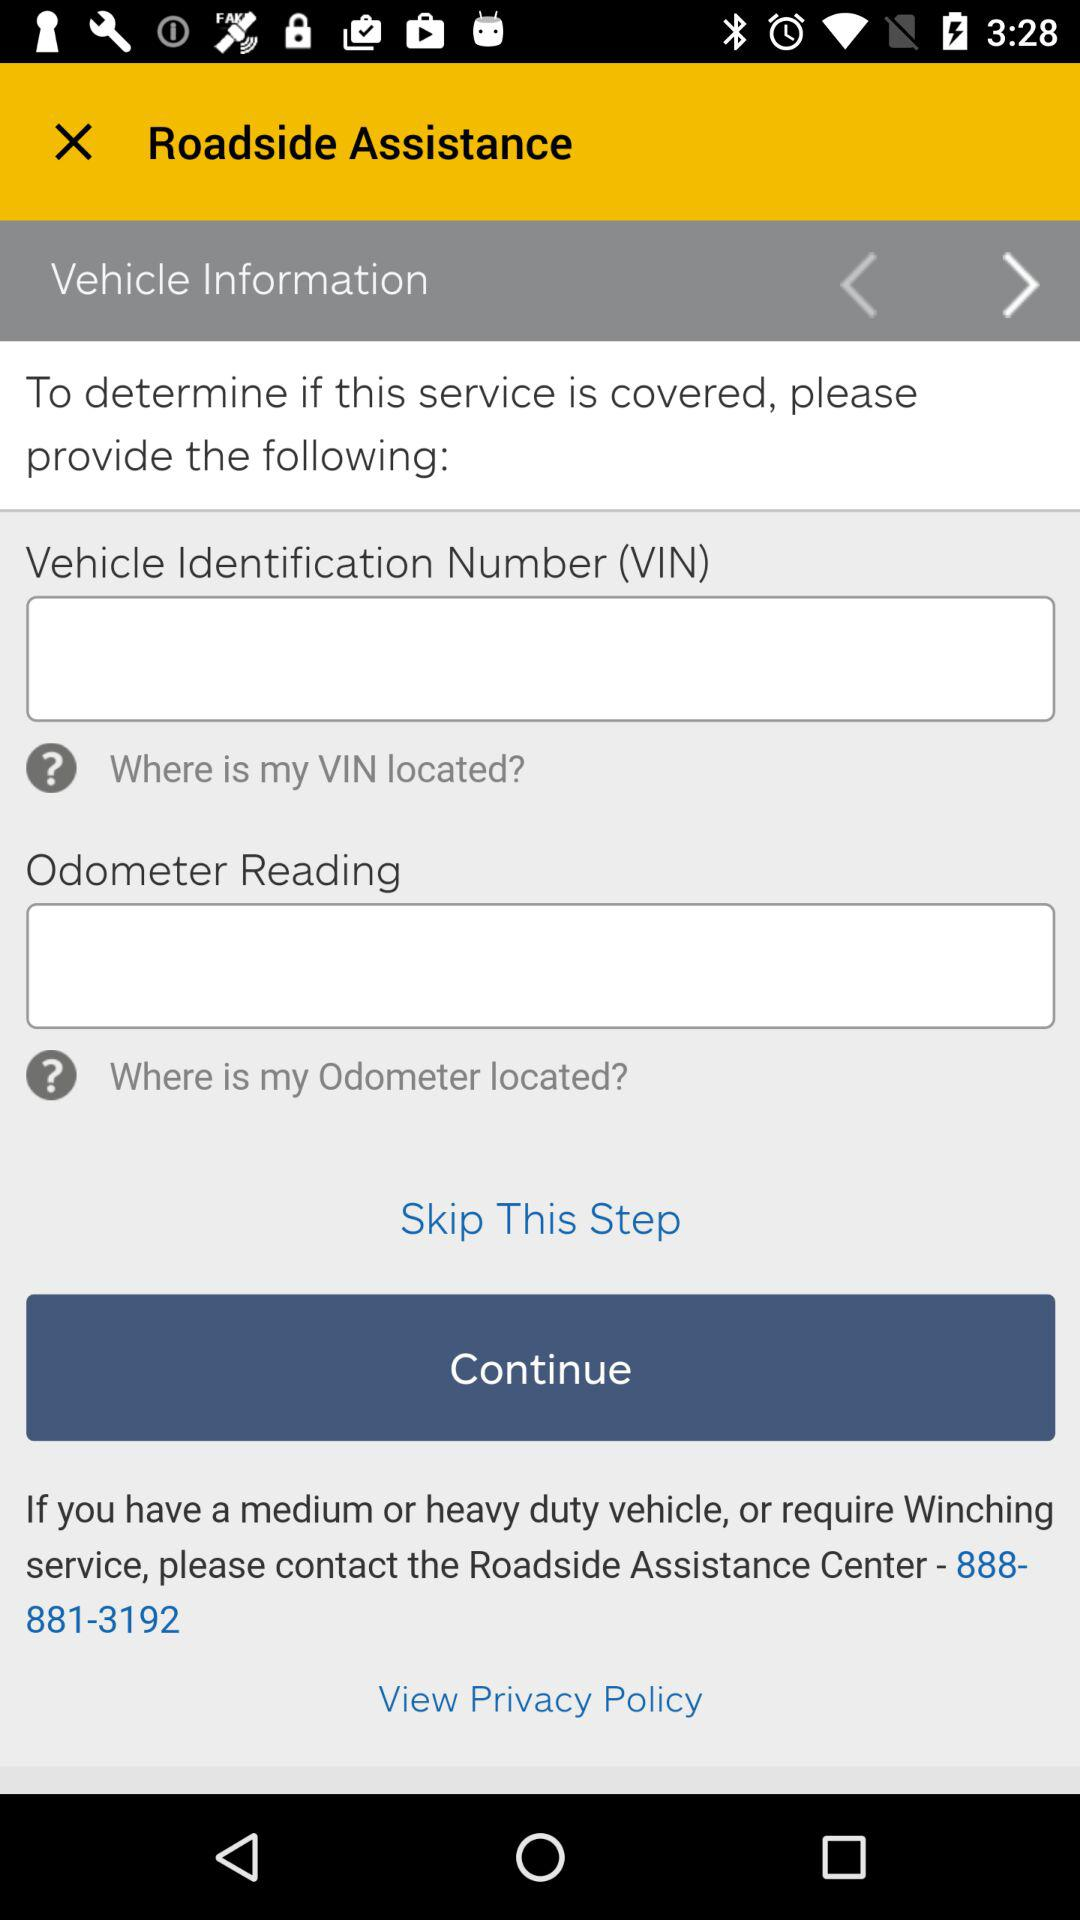What does "VIN" stands for? "VIN" stands for Vehicle Identification Number. 